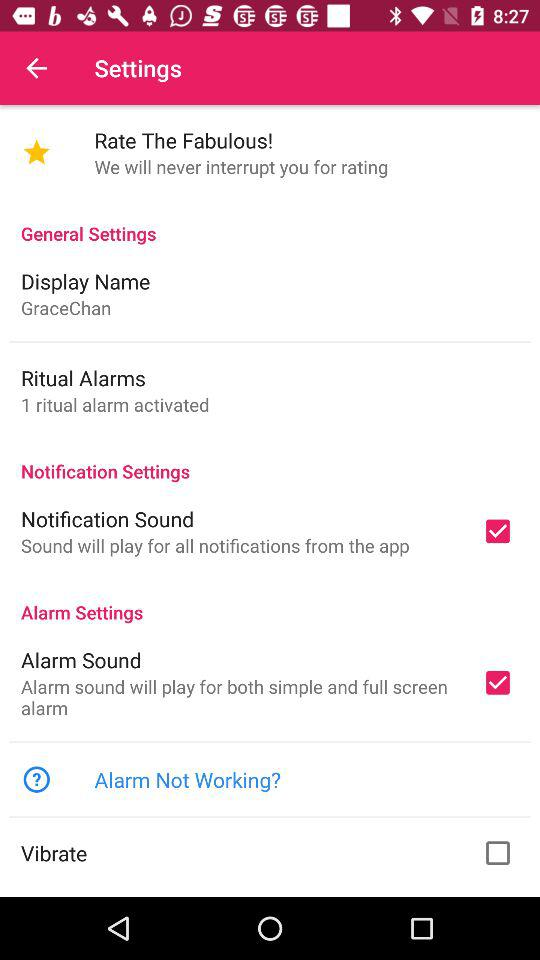How many ritual alarms are active? The active ritual alarm is 1. 